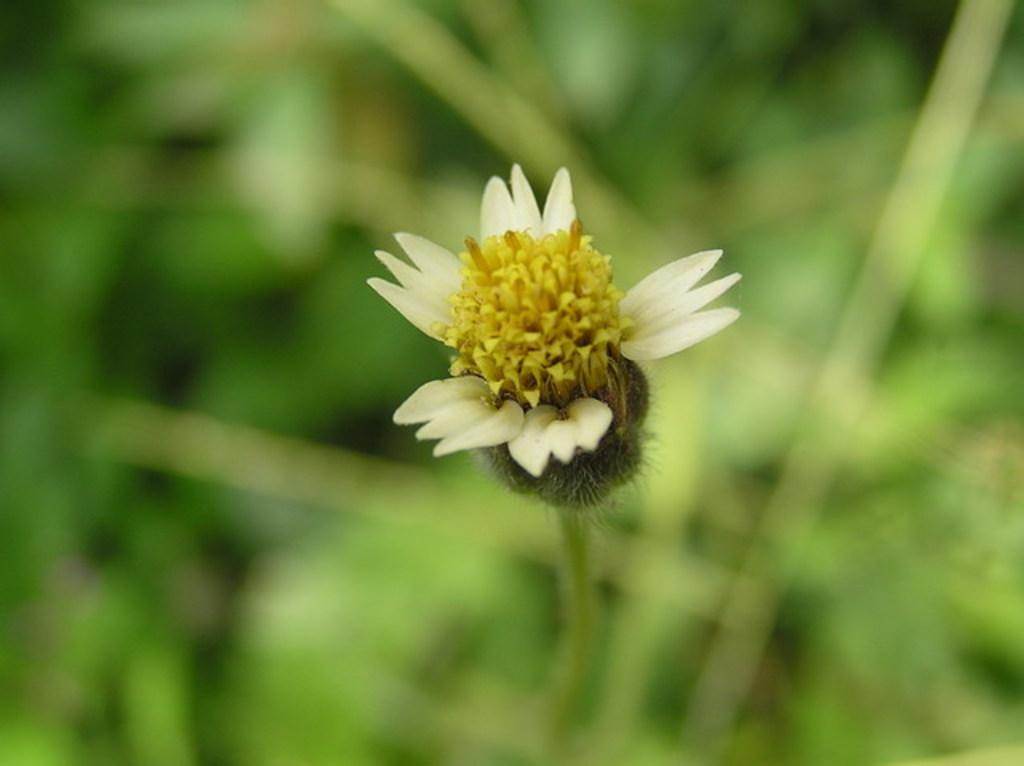What is the main subject of the image? There is a flower in the image. Can you describe the background of the image? The background of the image is blurred. What type of butter can be seen melting on the flower in the image? There is no butter present in the image; it features a flower with a blurred background. What is the zinc content of the flower in the image? There is no information about the zinc content of the flower in the image, as it is not a scientific analysis. 